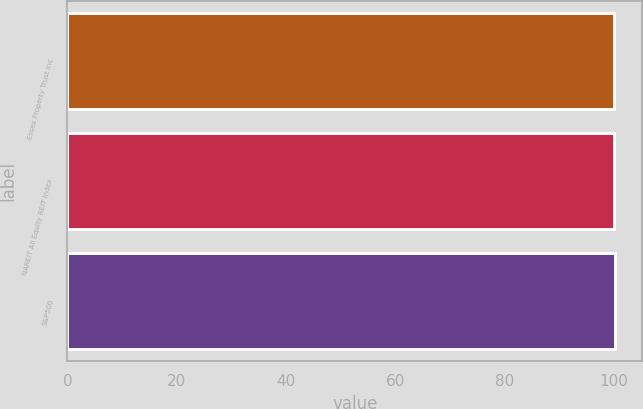Convert chart to OTSL. <chart><loc_0><loc_0><loc_500><loc_500><bar_chart><fcel>Essex Property Trust Inc<fcel>NAREIT All Equity REIT Index<fcel>S&P500<nl><fcel>100<fcel>100.1<fcel>100.2<nl></chart> 